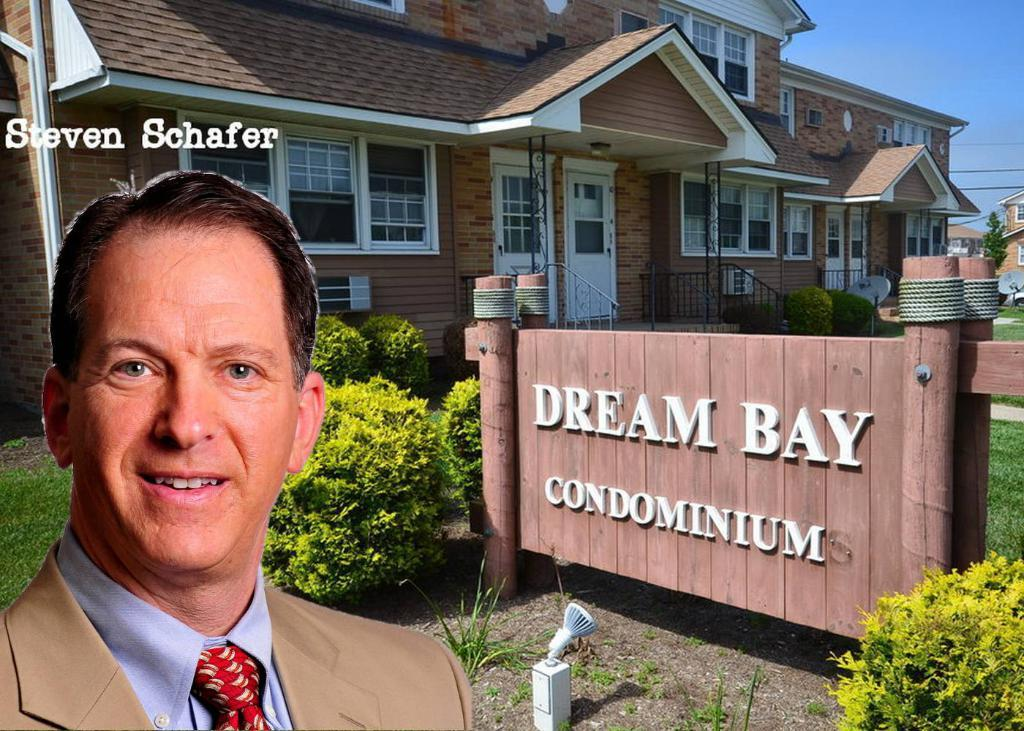What is the main subject of the image? There is a person in the image. Can you describe the person's attire? The person is wearing a coat and tie. What can be seen in the background of the image? There is a group of trees, a sign board, a light placed on the ground, a group of buildings, and the sky visible in the background of the image. How far away is the carriage from the person in the image? There is no carriage present in the image. What impulse might have led the person to wear a coat and tie in the image? We cannot determine the person's motivation for wearing a coat and tie from the image alone. 